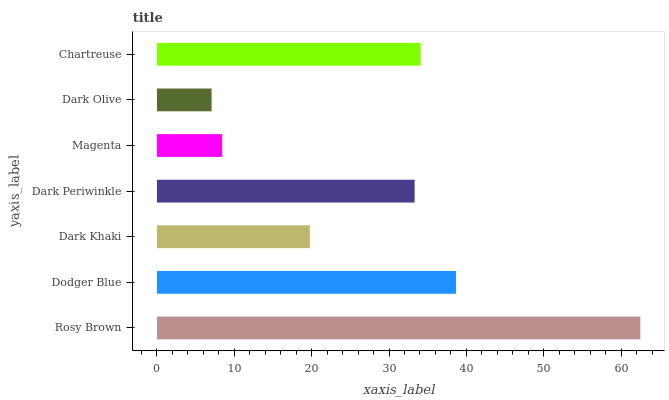Is Dark Olive the minimum?
Answer yes or no. Yes. Is Rosy Brown the maximum?
Answer yes or no. Yes. Is Dodger Blue the minimum?
Answer yes or no. No. Is Dodger Blue the maximum?
Answer yes or no. No. Is Rosy Brown greater than Dodger Blue?
Answer yes or no. Yes. Is Dodger Blue less than Rosy Brown?
Answer yes or no. Yes. Is Dodger Blue greater than Rosy Brown?
Answer yes or no. No. Is Rosy Brown less than Dodger Blue?
Answer yes or no. No. Is Dark Periwinkle the high median?
Answer yes or no. Yes. Is Dark Periwinkle the low median?
Answer yes or no. Yes. Is Dark Khaki the high median?
Answer yes or no. No. Is Rosy Brown the low median?
Answer yes or no. No. 